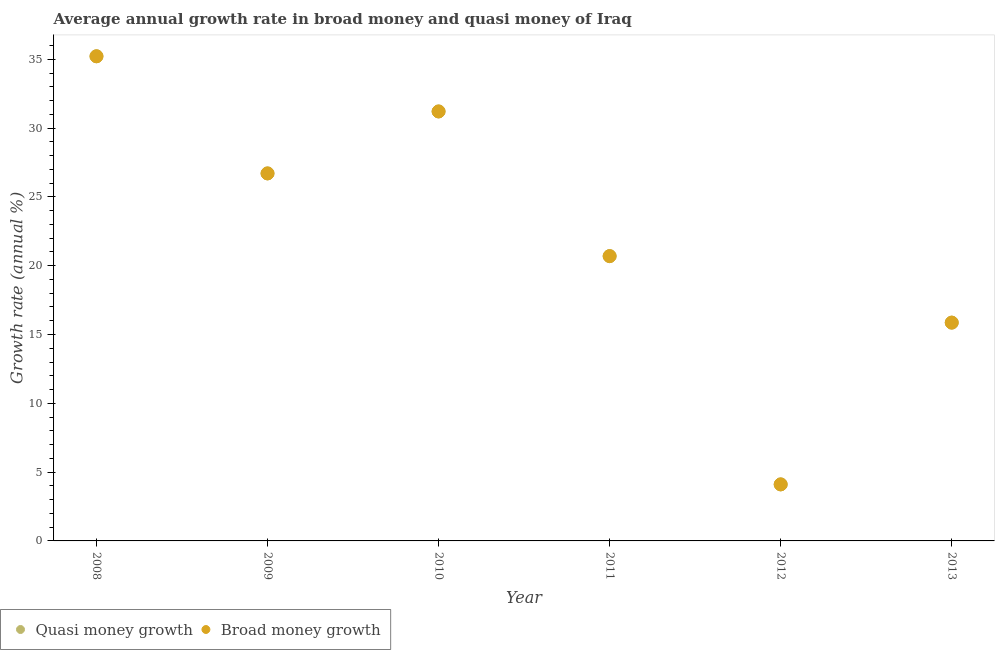How many different coloured dotlines are there?
Offer a very short reply. 2. Is the number of dotlines equal to the number of legend labels?
Ensure brevity in your answer.  Yes. What is the annual growth rate in broad money in 2012?
Offer a terse response. 4.11. Across all years, what is the maximum annual growth rate in broad money?
Ensure brevity in your answer.  35.22. Across all years, what is the minimum annual growth rate in broad money?
Your answer should be very brief. 4.11. What is the total annual growth rate in broad money in the graph?
Make the answer very short. 133.79. What is the difference between the annual growth rate in broad money in 2009 and that in 2010?
Give a very brief answer. -4.5. What is the difference between the annual growth rate in broad money in 2012 and the annual growth rate in quasi money in 2013?
Give a very brief answer. -11.75. What is the average annual growth rate in broad money per year?
Provide a succinct answer. 22.3. In the year 2010, what is the difference between the annual growth rate in broad money and annual growth rate in quasi money?
Keep it short and to the point. 0. In how many years, is the annual growth rate in broad money greater than 1 %?
Your response must be concise. 6. What is the ratio of the annual growth rate in broad money in 2009 to that in 2013?
Your answer should be compact. 1.68. Is the annual growth rate in broad money in 2008 less than that in 2012?
Provide a succinct answer. No. What is the difference between the highest and the second highest annual growth rate in broad money?
Provide a succinct answer. 4.01. What is the difference between the highest and the lowest annual growth rate in quasi money?
Ensure brevity in your answer.  31.11. Is the annual growth rate in quasi money strictly greater than the annual growth rate in broad money over the years?
Give a very brief answer. No. How many dotlines are there?
Offer a terse response. 2. What is the difference between two consecutive major ticks on the Y-axis?
Your answer should be very brief. 5. Are the values on the major ticks of Y-axis written in scientific E-notation?
Your answer should be compact. No. How many legend labels are there?
Provide a succinct answer. 2. What is the title of the graph?
Offer a very short reply. Average annual growth rate in broad money and quasi money of Iraq. What is the label or title of the X-axis?
Provide a short and direct response. Year. What is the label or title of the Y-axis?
Your answer should be compact. Growth rate (annual %). What is the Growth rate (annual %) of Quasi money growth in 2008?
Make the answer very short. 35.22. What is the Growth rate (annual %) of Broad money growth in 2008?
Your answer should be very brief. 35.22. What is the Growth rate (annual %) in Quasi money growth in 2009?
Ensure brevity in your answer.  26.7. What is the Growth rate (annual %) in Broad money growth in 2009?
Give a very brief answer. 26.7. What is the Growth rate (annual %) of Quasi money growth in 2010?
Your answer should be compact. 31.21. What is the Growth rate (annual %) in Broad money growth in 2010?
Provide a short and direct response. 31.21. What is the Growth rate (annual %) of Quasi money growth in 2011?
Give a very brief answer. 20.69. What is the Growth rate (annual %) of Broad money growth in 2011?
Your answer should be compact. 20.69. What is the Growth rate (annual %) of Quasi money growth in 2012?
Your response must be concise. 4.11. What is the Growth rate (annual %) in Broad money growth in 2012?
Ensure brevity in your answer.  4.11. What is the Growth rate (annual %) of Quasi money growth in 2013?
Provide a short and direct response. 15.86. What is the Growth rate (annual %) of Broad money growth in 2013?
Offer a very short reply. 15.86. Across all years, what is the maximum Growth rate (annual %) in Quasi money growth?
Provide a short and direct response. 35.22. Across all years, what is the maximum Growth rate (annual %) in Broad money growth?
Your response must be concise. 35.22. Across all years, what is the minimum Growth rate (annual %) in Quasi money growth?
Your response must be concise. 4.11. Across all years, what is the minimum Growth rate (annual %) in Broad money growth?
Your response must be concise. 4.11. What is the total Growth rate (annual %) in Quasi money growth in the graph?
Keep it short and to the point. 133.79. What is the total Growth rate (annual %) in Broad money growth in the graph?
Offer a very short reply. 133.79. What is the difference between the Growth rate (annual %) in Quasi money growth in 2008 and that in 2009?
Your response must be concise. 8.51. What is the difference between the Growth rate (annual %) in Broad money growth in 2008 and that in 2009?
Your answer should be compact. 8.51. What is the difference between the Growth rate (annual %) in Quasi money growth in 2008 and that in 2010?
Make the answer very short. 4.01. What is the difference between the Growth rate (annual %) in Broad money growth in 2008 and that in 2010?
Your answer should be very brief. 4.01. What is the difference between the Growth rate (annual %) in Quasi money growth in 2008 and that in 2011?
Your answer should be very brief. 14.52. What is the difference between the Growth rate (annual %) of Broad money growth in 2008 and that in 2011?
Your answer should be compact. 14.52. What is the difference between the Growth rate (annual %) in Quasi money growth in 2008 and that in 2012?
Your answer should be compact. 31.11. What is the difference between the Growth rate (annual %) in Broad money growth in 2008 and that in 2012?
Give a very brief answer. 31.11. What is the difference between the Growth rate (annual %) in Quasi money growth in 2008 and that in 2013?
Provide a short and direct response. 19.35. What is the difference between the Growth rate (annual %) of Broad money growth in 2008 and that in 2013?
Keep it short and to the point. 19.35. What is the difference between the Growth rate (annual %) in Quasi money growth in 2009 and that in 2010?
Provide a succinct answer. -4.5. What is the difference between the Growth rate (annual %) in Broad money growth in 2009 and that in 2010?
Keep it short and to the point. -4.5. What is the difference between the Growth rate (annual %) of Quasi money growth in 2009 and that in 2011?
Give a very brief answer. 6.01. What is the difference between the Growth rate (annual %) in Broad money growth in 2009 and that in 2011?
Make the answer very short. 6.01. What is the difference between the Growth rate (annual %) in Quasi money growth in 2009 and that in 2012?
Make the answer very short. 22.6. What is the difference between the Growth rate (annual %) in Broad money growth in 2009 and that in 2012?
Offer a terse response. 22.6. What is the difference between the Growth rate (annual %) of Quasi money growth in 2009 and that in 2013?
Your response must be concise. 10.84. What is the difference between the Growth rate (annual %) in Broad money growth in 2009 and that in 2013?
Offer a terse response. 10.84. What is the difference between the Growth rate (annual %) of Quasi money growth in 2010 and that in 2011?
Make the answer very short. 10.51. What is the difference between the Growth rate (annual %) in Broad money growth in 2010 and that in 2011?
Ensure brevity in your answer.  10.51. What is the difference between the Growth rate (annual %) of Quasi money growth in 2010 and that in 2012?
Provide a short and direct response. 27.1. What is the difference between the Growth rate (annual %) of Broad money growth in 2010 and that in 2012?
Make the answer very short. 27.1. What is the difference between the Growth rate (annual %) in Quasi money growth in 2010 and that in 2013?
Provide a succinct answer. 15.34. What is the difference between the Growth rate (annual %) in Broad money growth in 2010 and that in 2013?
Provide a succinct answer. 15.34. What is the difference between the Growth rate (annual %) in Quasi money growth in 2011 and that in 2012?
Offer a terse response. 16.59. What is the difference between the Growth rate (annual %) of Broad money growth in 2011 and that in 2012?
Your answer should be compact. 16.59. What is the difference between the Growth rate (annual %) in Quasi money growth in 2011 and that in 2013?
Provide a succinct answer. 4.83. What is the difference between the Growth rate (annual %) in Broad money growth in 2011 and that in 2013?
Your response must be concise. 4.83. What is the difference between the Growth rate (annual %) of Quasi money growth in 2012 and that in 2013?
Keep it short and to the point. -11.75. What is the difference between the Growth rate (annual %) in Broad money growth in 2012 and that in 2013?
Offer a very short reply. -11.75. What is the difference between the Growth rate (annual %) of Quasi money growth in 2008 and the Growth rate (annual %) of Broad money growth in 2009?
Your answer should be compact. 8.51. What is the difference between the Growth rate (annual %) of Quasi money growth in 2008 and the Growth rate (annual %) of Broad money growth in 2010?
Your response must be concise. 4.01. What is the difference between the Growth rate (annual %) in Quasi money growth in 2008 and the Growth rate (annual %) in Broad money growth in 2011?
Make the answer very short. 14.52. What is the difference between the Growth rate (annual %) of Quasi money growth in 2008 and the Growth rate (annual %) of Broad money growth in 2012?
Your response must be concise. 31.11. What is the difference between the Growth rate (annual %) of Quasi money growth in 2008 and the Growth rate (annual %) of Broad money growth in 2013?
Offer a terse response. 19.35. What is the difference between the Growth rate (annual %) in Quasi money growth in 2009 and the Growth rate (annual %) in Broad money growth in 2010?
Offer a very short reply. -4.5. What is the difference between the Growth rate (annual %) of Quasi money growth in 2009 and the Growth rate (annual %) of Broad money growth in 2011?
Make the answer very short. 6.01. What is the difference between the Growth rate (annual %) in Quasi money growth in 2009 and the Growth rate (annual %) in Broad money growth in 2012?
Ensure brevity in your answer.  22.6. What is the difference between the Growth rate (annual %) in Quasi money growth in 2009 and the Growth rate (annual %) in Broad money growth in 2013?
Keep it short and to the point. 10.84. What is the difference between the Growth rate (annual %) of Quasi money growth in 2010 and the Growth rate (annual %) of Broad money growth in 2011?
Keep it short and to the point. 10.51. What is the difference between the Growth rate (annual %) in Quasi money growth in 2010 and the Growth rate (annual %) in Broad money growth in 2012?
Give a very brief answer. 27.1. What is the difference between the Growth rate (annual %) of Quasi money growth in 2010 and the Growth rate (annual %) of Broad money growth in 2013?
Keep it short and to the point. 15.34. What is the difference between the Growth rate (annual %) of Quasi money growth in 2011 and the Growth rate (annual %) of Broad money growth in 2012?
Offer a terse response. 16.59. What is the difference between the Growth rate (annual %) in Quasi money growth in 2011 and the Growth rate (annual %) in Broad money growth in 2013?
Offer a very short reply. 4.83. What is the difference between the Growth rate (annual %) of Quasi money growth in 2012 and the Growth rate (annual %) of Broad money growth in 2013?
Offer a terse response. -11.75. What is the average Growth rate (annual %) of Quasi money growth per year?
Offer a terse response. 22.3. What is the average Growth rate (annual %) of Broad money growth per year?
Ensure brevity in your answer.  22.3. In the year 2008, what is the difference between the Growth rate (annual %) in Quasi money growth and Growth rate (annual %) in Broad money growth?
Ensure brevity in your answer.  0. In the year 2010, what is the difference between the Growth rate (annual %) of Quasi money growth and Growth rate (annual %) of Broad money growth?
Your response must be concise. 0. In the year 2012, what is the difference between the Growth rate (annual %) in Quasi money growth and Growth rate (annual %) in Broad money growth?
Provide a short and direct response. 0. What is the ratio of the Growth rate (annual %) of Quasi money growth in 2008 to that in 2009?
Ensure brevity in your answer.  1.32. What is the ratio of the Growth rate (annual %) of Broad money growth in 2008 to that in 2009?
Ensure brevity in your answer.  1.32. What is the ratio of the Growth rate (annual %) in Quasi money growth in 2008 to that in 2010?
Make the answer very short. 1.13. What is the ratio of the Growth rate (annual %) of Broad money growth in 2008 to that in 2010?
Your answer should be compact. 1.13. What is the ratio of the Growth rate (annual %) of Quasi money growth in 2008 to that in 2011?
Offer a very short reply. 1.7. What is the ratio of the Growth rate (annual %) in Broad money growth in 2008 to that in 2011?
Give a very brief answer. 1.7. What is the ratio of the Growth rate (annual %) of Quasi money growth in 2008 to that in 2012?
Keep it short and to the point. 8.57. What is the ratio of the Growth rate (annual %) in Broad money growth in 2008 to that in 2012?
Provide a short and direct response. 8.57. What is the ratio of the Growth rate (annual %) in Quasi money growth in 2008 to that in 2013?
Give a very brief answer. 2.22. What is the ratio of the Growth rate (annual %) in Broad money growth in 2008 to that in 2013?
Your answer should be compact. 2.22. What is the ratio of the Growth rate (annual %) in Quasi money growth in 2009 to that in 2010?
Make the answer very short. 0.86. What is the ratio of the Growth rate (annual %) in Broad money growth in 2009 to that in 2010?
Give a very brief answer. 0.86. What is the ratio of the Growth rate (annual %) in Quasi money growth in 2009 to that in 2011?
Make the answer very short. 1.29. What is the ratio of the Growth rate (annual %) in Broad money growth in 2009 to that in 2011?
Make the answer very short. 1.29. What is the ratio of the Growth rate (annual %) in Quasi money growth in 2009 to that in 2013?
Your response must be concise. 1.68. What is the ratio of the Growth rate (annual %) in Broad money growth in 2009 to that in 2013?
Keep it short and to the point. 1.68. What is the ratio of the Growth rate (annual %) of Quasi money growth in 2010 to that in 2011?
Ensure brevity in your answer.  1.51. What is the ratio of the Growth rate (annual %) of Broad money growth in 2010 to that in 2011?
Your answer should be very brief. 1.51. What is the ratio of the Growth rate (annual %) of Quasi money growth in 2010 to that in 2012?
Keep it short and to the point. 7.6. What is the ratio of the Growth rate (annual %) in Broad money growth in 2010 to that in 2012?
Keep it short and to the point. 7.6. What is the ratio of the Growth rate (annual %) of Quasi money growth in 2010 to that in 2013?
Provide a succinct answer. 1.97. What is the ratio of the Growth rate (annual %) in Broad money growth in 2010 to that in 2013?
Give a very brief answer. 1.97. What is the ratio of the Growth rate (annual %) in Quasi money growth in 2011 to that in 2012?
Ensure brevity in your answer.  5.04. What is the ratio of the Growth rate (annual %) in Broad money growth in 2011 to that in 2012?
Offer a very short reply. 5.04. What is the ratio of the Growth rate (annual %) in Quasi money growth in 2011 to that in 2013?
Give a very brief answer. 1.3. What is the ratio of the Growth rate (annual %) of Broad money growth in 2011 to that in 2013?
Your answer should be very brief. 1.3. What is the ratio of the Growth rate (annual %) of Quasi money growth in 2012 to that in 2013?
Give a very brief answer. 0.26. What is the ratio of the Growth rate (annual %) of Broad money growth in 2012 to that in 2013?
Make the answer very short. 0.26. What is the difference between the highest and the second highest Growth rate (annual %) of Quasi money growth?
Make the answer very short. 4.01. What is the difference between the highest and the second highest Growth rate (annual %) of Broad money growth?
Your answer should be very brief. 4.01. What is the difference between the highest and the lowest Growth rate (annual %) in Quasi money growth?
Ensure brevity in your answer.  31.11. What is the difference between the highest and the lowest Growth rate (annual %) of Broad money growth?
Your answer should be compact. 31.11. 